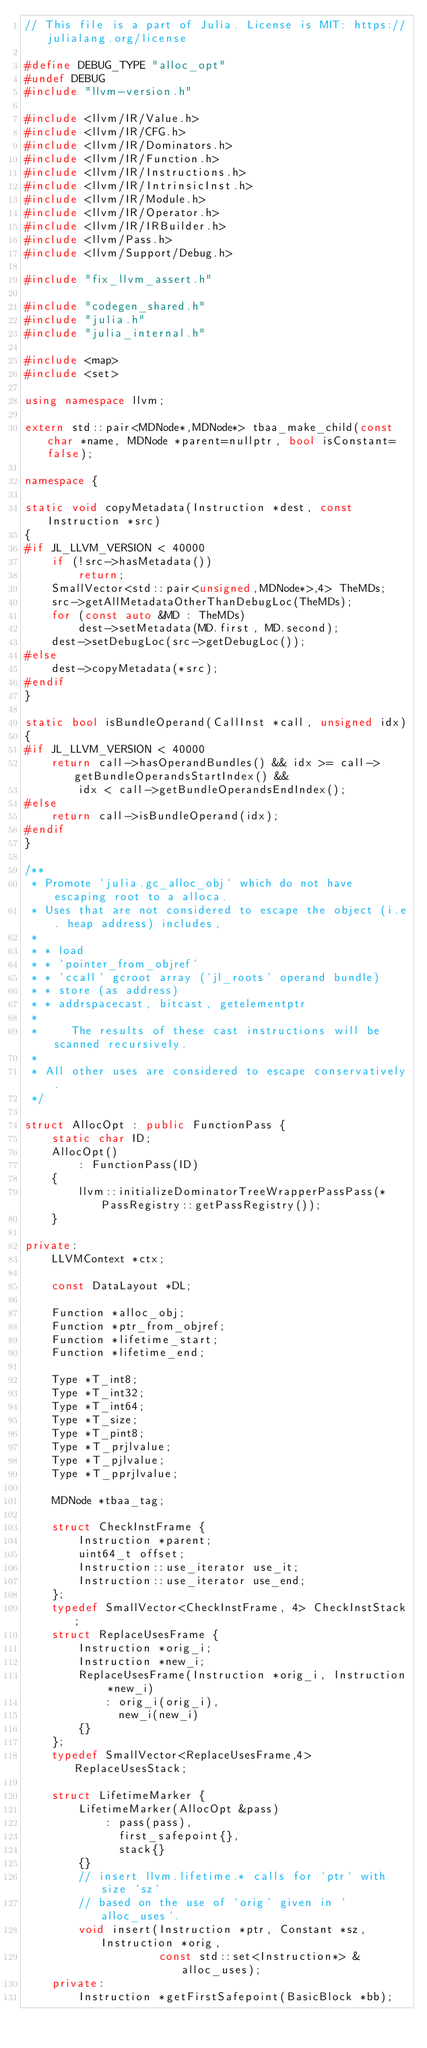<code> <loc_0><loc_0><loc_500><loc_500><_C++_>// This file is a part of Julia. License is MIT: https://julialang.org/license

#define DEBUG_TYPE "alloc_opt"
#undef DEBUG
#include "llvm-version.h"

#include <llvm/IR/Value.h>
#include <llvm/IR/CFG.h>
#include <llvm/IR/Dominators.h>
#include <llvm/IR/Function.h>
#include <llvm/IR/Instructions.h>
#include <llvm/IR/IntrinsicInst.h>
#include <llvm/IR/Module.h>
#include <llvm/IR/Operator.h>
#include <llvm/IR/IRBuilder.h>
#include <llvm/Pass.h>
#include <llvm/Support/Debug.h>

#include "fix_llvm_assert.h"

#include "codegen_shared.h"
#include "julia.h"
#include "julia_internal.h"

#include <map>
#include <set>

using namespace llvm;

extern std::pair<MDNode*,MDNode*> tbaa_make_child(const char *name, MDNode *parent=nullptr, bool isConstant=false);

namespace {

static void copyMetadata(Instruction *dest, const Instruction *src)
{
#if JL_LLVM_VERSION < 40000
    if (!src->hasMetadata())
        return;
    SmallVector<std::pair<unsigned,MDNode*>,4> TheMDs;
    src->getAllMetadataOtherThanDebugLoc(TheMDs);
    for (const auto &MD : TheMDs)
        dest->setMetadata(MD.first, MD.second);
    dest->setDebugLoc(src->getDebugLoc());
#else
    dest->copyMetadata(*src);
#endif
}

static bool isBundleOperand(CallInst *call, unsigned idx)
{
#if JL_LLVM_VERSION < 40000
    return call->hasOperandBundles() && idx >= call->getBundleOperandsStartIndex() &&
        idx < call->getBundleOperandsEndIndex();
#else
    return call->isBundleOperand(idx);
#endif
}

/**
 * Promote `julia.gc_alloc_obj` which do not have escaping root to a alloca.
 * Uses that are not considered to escape the object (i.e. heap address) includes,
 *
 * * load
 * * `pointer_from_objref`
 * * `ccall` gcroot array (`jl_roots` operand bundle)
 * * store (as address)
 * * addrspacecast, bitcast, getelementptr
 *
 *     The results of these cast instructions will be scanned recursively.
 *
 * All other uses are considered to escape conservatively.
 */

struct AllocOpt : public FunctionPass {
    static char ID;
    AllocOpt()
        : FunctionPass(ID)
    {
        llvm::initializeDominatorTreeWrapperPassPass(*PassRegistry::getPassRegistry());
    }

private:
    LLVMContext *ctx;

    const DataLayout *DL;

    Function *alloc_obj;
    Function *ptr_from_objref;
    Function *lifetime_start;
    Function *lifetime_end;

    Type *T_int8;
    Type *T_int32;
    Type *T_int64;
    Type *T_size;
    Type *T_pint8;
    Type *T_prjlvalue;
    Type *T_pjlvalue;
    Type *T_pprjlvalue;

    MDNode *tbaa_tag;

    struct CheckInstFrame {
        Instruction *parent;
        uint64_t offset;
        Instruction::use_iterator use_it;
        Instruction::use_iterator use_end;
    };
    typedef SmallVector<CheckInstFrame, 4> CheckInstStack;
    struct ReplaceUsesFrame {
        Instruction *orig_i;
        Instruction *new_i;
        ReplaceUsesFrame(Instruction *orig_i, Instruction *new_i)
            : orig_i(orig_i),
              new_i(new_i)
        {}
    };
    typedef SmallVector<ReplaceUsesFrame,4> ReplaceUsesStack;

    struct LifetimeMarker {
        LifetimeMarker(AllocOpt &pass)
            : pass(pass),
              first_safepoint{},
              stack{}
        {}
        // insert llvm.lifetime.* calls for `ptr` with size `sz`
        // based on the use of `orig` given in `alloc_uses`.
        void insert(Instruction *ptr, Constant *sz, Instruction *orig,
                    const std::set<Instruction*> &alloc_uses);
    private:
        Instruction *getFirstSafepoint(BasicBlock *bb);</code> 